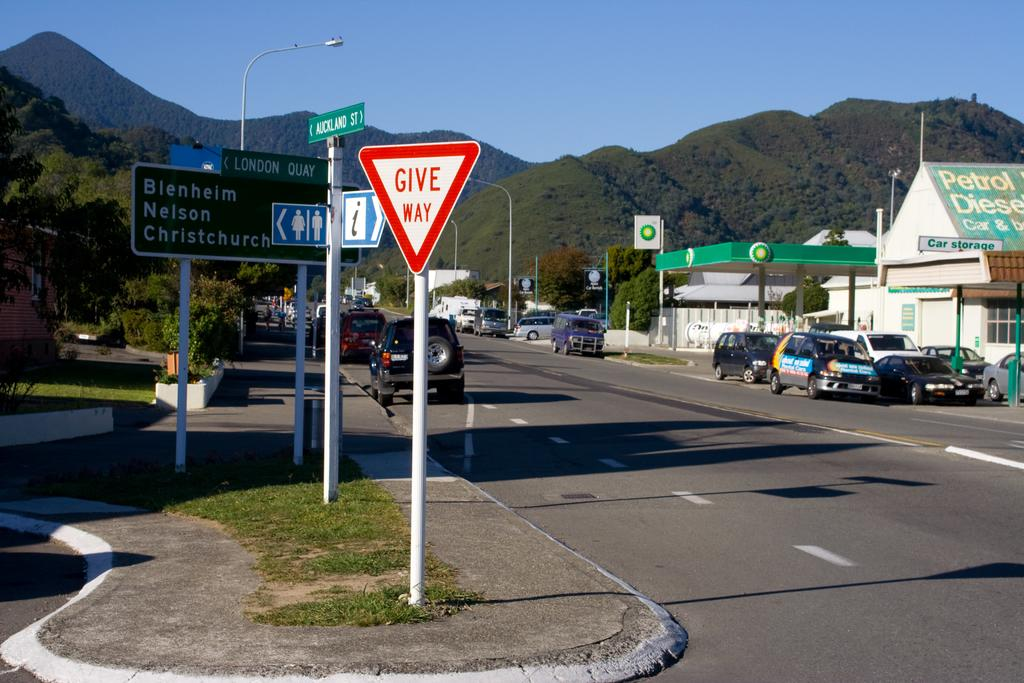<image>
Relay a brief, clear account of the picture shown. a give way sign that is red in color and outside 